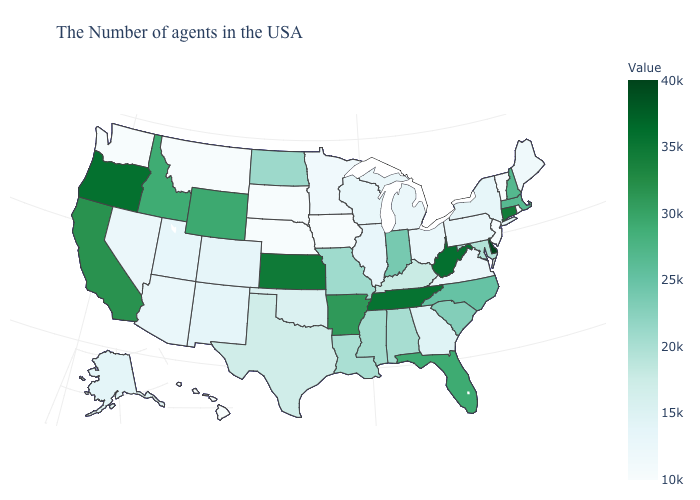Is the legend a continuous bar?
Answer briefly. Yes. Which states have the lowest value in the USA?
Keep it brief. Rhode Island, Vermont, New Jersey, Iowa, Nebraska, South Dakota, Montana, Washington, Hawaii. Among the states that border Illinois , which have the lowest value?
Be succinct. Iowa. Is the legend a continuous bar?
Be succinct. Yes. Among the states that border West Virginia , which have the highest value?
Quick response, please. Maryland. Is the legend a continuous bar?
Write a very short answer. Yes. Which states hav the highest value in the MidWest?
Keep it brief. Kansas. 